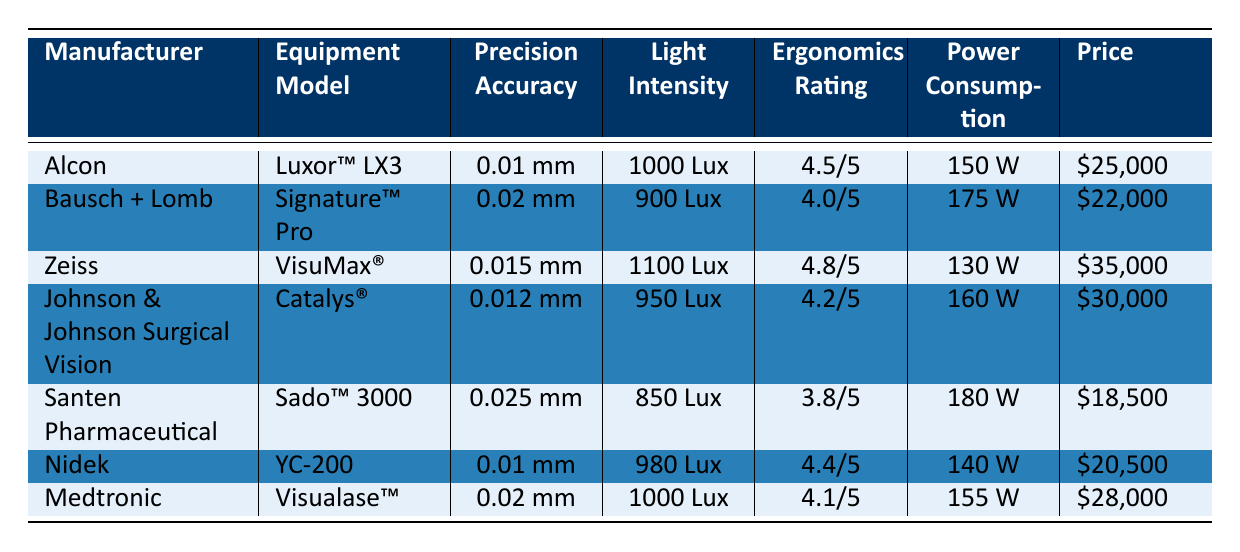What is the precision accuracy of the Luxor™ LX3 by Alcon? The table lists the precision accuracy of the Luxor™ LX3 under the column for precision accuracy, showing it as 0.01 mm.
Answer: 0.01 mm Which equipment has the highest light intensity? By examining the light intensity column, the VisuMax® by Zeiss shows the highest value at 1100 Lux.
Answer: 1100 Lux Is the power consumption of the Signature™ Pro less than 160 W? The power consumption for the Signature™ Pro is listed as 175 W, which is greater than 160 W. Therefore, this statement is false.
Answer: No What is the average ergonomics rating of the surgical equipment listed? The ergonomics ratings are: 4.5, 4.0, 4.8, 4.2, 3.8, 4.4, and 4.1. Adding these gives a total of 27.0. There are 7 ratings, so the average is 27.0/7 = 3.857, or approximately 3.86 when rounded to two decimal places.
Answer: 3.86 Which manufacturer has the lowest price equipment? Comparing the prices listed under the price column, Santen Pharmaceutical with Sado™ 3000 has the lowest price at $18,500.
Answer: $18,500 Does the equipment from Nidek have better precision accuracy than that from Bausch + Lomb? The precision accuracy for Nidek's YC-200 is 0.01 mm, while Bausch + Lomb's Signature™ Pro has 0.02 mm. Since 0.01 mm is better than 0.02 mm in surgical equipment precision, it confirms Nidek has better accuracy.
Answer: Yes How much more power does the Catalyst® consume compared to the Luxor™ LX3? The power consumption for the Catalys® is 160 W, and for the Luxor™ LX3 it is 150 W. The difference is 160 W - 150 W = 10 W.
Answer: 10 W What is the total power consumption of all the equipment listed? The power consumption values are 150 W, 175 W, 130 W, 160 W, 180 W, 140 W, and 155 W. Adding them gives a total of 1090 W (150 + 175 + 130 + 160 + 180 + 140 + 155).
Answer: 1090 W Which equipment has the highest ergonomics rating? Reviewing the ergonomics ratings, Zeiss's VisuMax® at 4.8/5 has the highest rating when compared to others.
Answer: 4.8/5 If we compare the prices of Nidek's YC-200 and Medtronic's Visualase™, how much more expensive is the Visualase™? The price for Nidek's YC-200 is $20,500 and for Medtronic's Visualase™ it is $28,000. The difference is $28,000 - $20,500 = $7,500, indicating the Visualase™ is $7,500 more expensive.
Answer: $7,500 